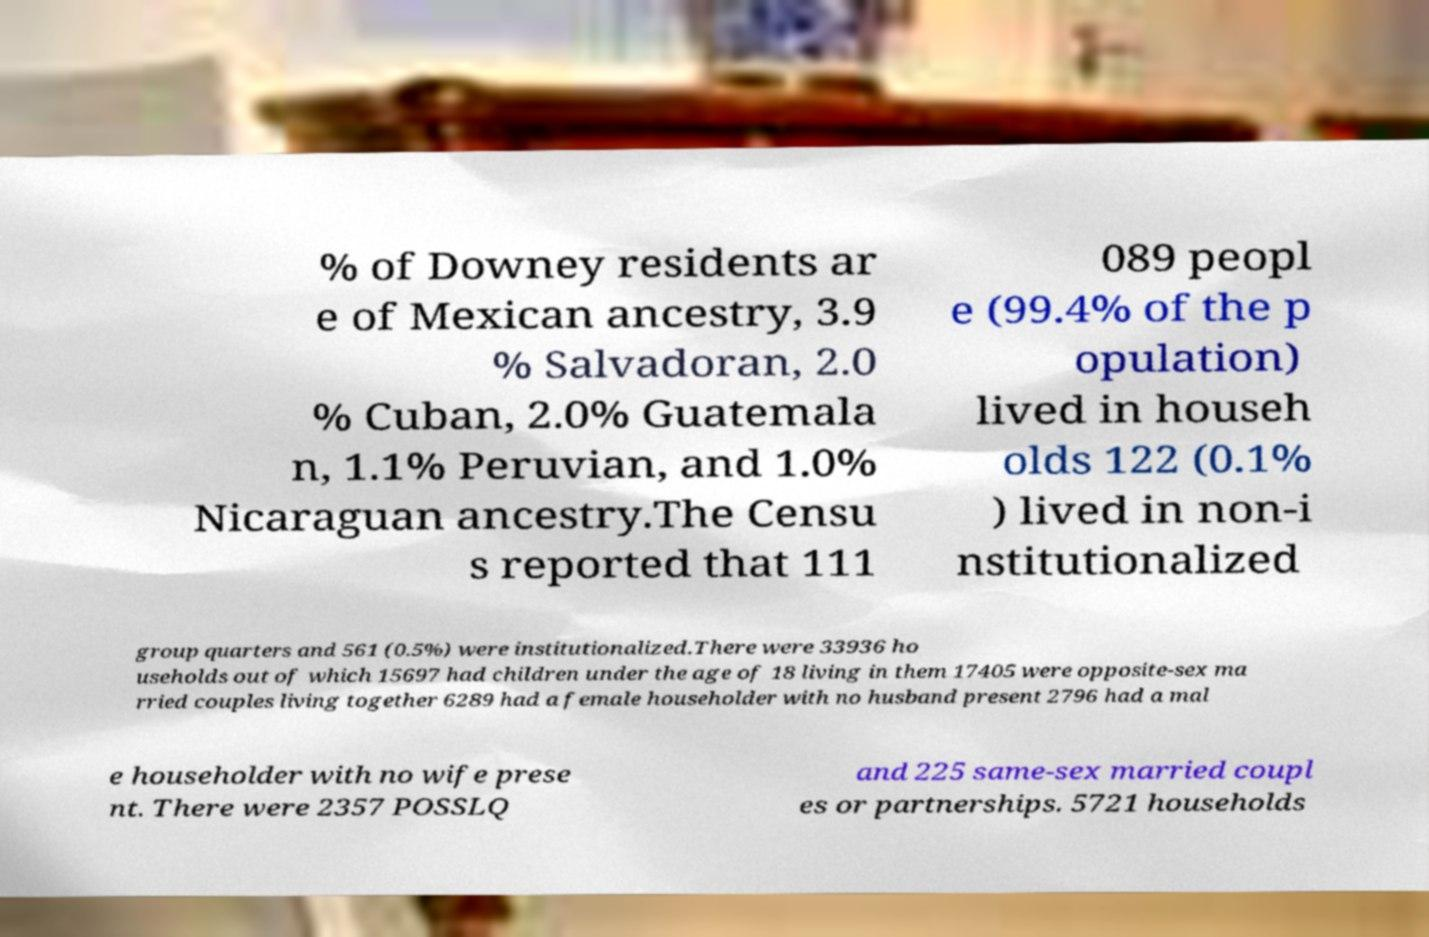Please read and relay the text visible in this image. What does it say? % of Downey residents ar e of Mexican ancestry, 3.9 % Salvadoran, 2.0 % Cuban, 2.0% Guatemala n, 1.1% Peruvian, and 1.0% Nicaraguan ancestry.The Censu s reported that 111 089 peopl e (99.4% of the p opulation) lived in househ olds 122 (0.1% ) lived in non-i nstitutionalized group quarters and 561 (0.5%) were institutionalized.There were 33936 ho useholds out of which 15697 had children under the age of 18 living in them 17405 were opposite-sex ma rried couples living together 6289 had a female householder with no husband present 2796 had a mal e householder with no wife prese nt. There were 2357 POSSLQ and 225 same-sex married coupl es or partnerships. 5721 households 